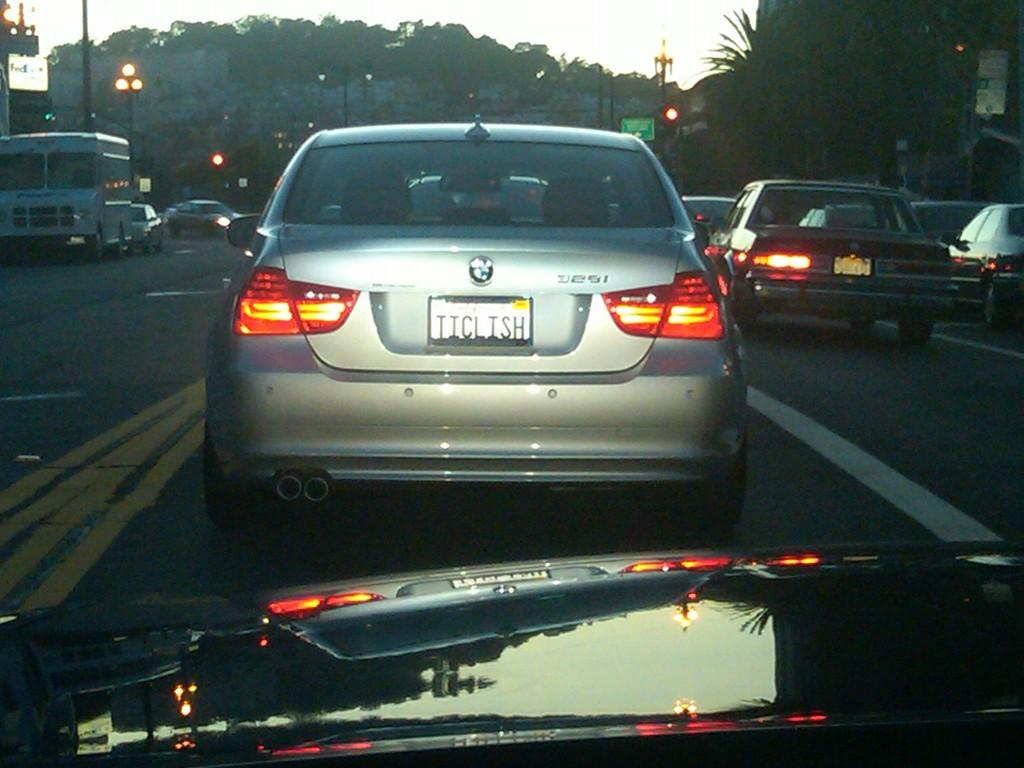<image>
Render a clear and concise summary of the photo. A BMW is driving with the license plate Ticlish. 